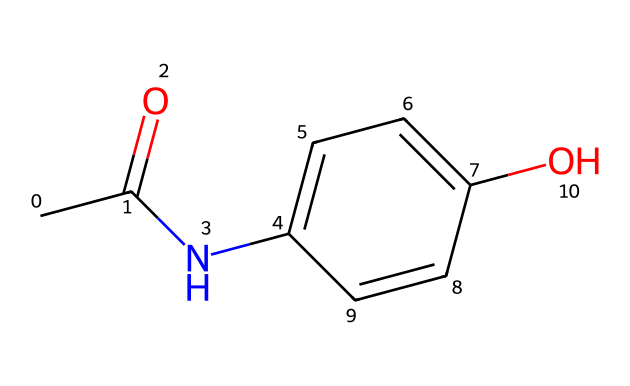What is the molecular formula of acetaminophen? The molecular formula can be derived from the SMILES notation, counting the atoms present: there are 8 carbon (C) atoms, 9 hydrogen (H) atoms, 1 nitrogen (N) atom, and 1 oxygen (O) atom. This gives the formula C8H9NO2.
Answer: C8H9NO2 How many rings are present in the structure of acetaminophen? By analyzing the SMILES notation, the piece "C1=CC=C(C=C1)" indicates a cyclic structure, which denotes a single ring. There are no other ring structures indicated in the SMILES.
Answer: 1 What functional groups are present in acetaminophen? The SMILES shows the presence of an amide (NC) and a hydroxyl (O) group, which are identifiable from their chemical symbols and positions in the structure.
Answer: amide and hydroxyl What type of compound is acetaminophen classified as? Acetaminophen is classified as an analgesic and antipyretic based on its common use as a pain reliever and fever reducer, and this classification is standard for substances with a similar structure.
Answer: analgesic and antipyretic How many hydrogen atoms are bonded to the nitrogen atom in acetaminophen? The SMILES notation shows a nitrogen (N) directly bonded to a carbon (C) and does not indicate any additional hydrogen attachments to the nitrogen. There is no explicit hydrogen shown in the representation.
Answer: 1 